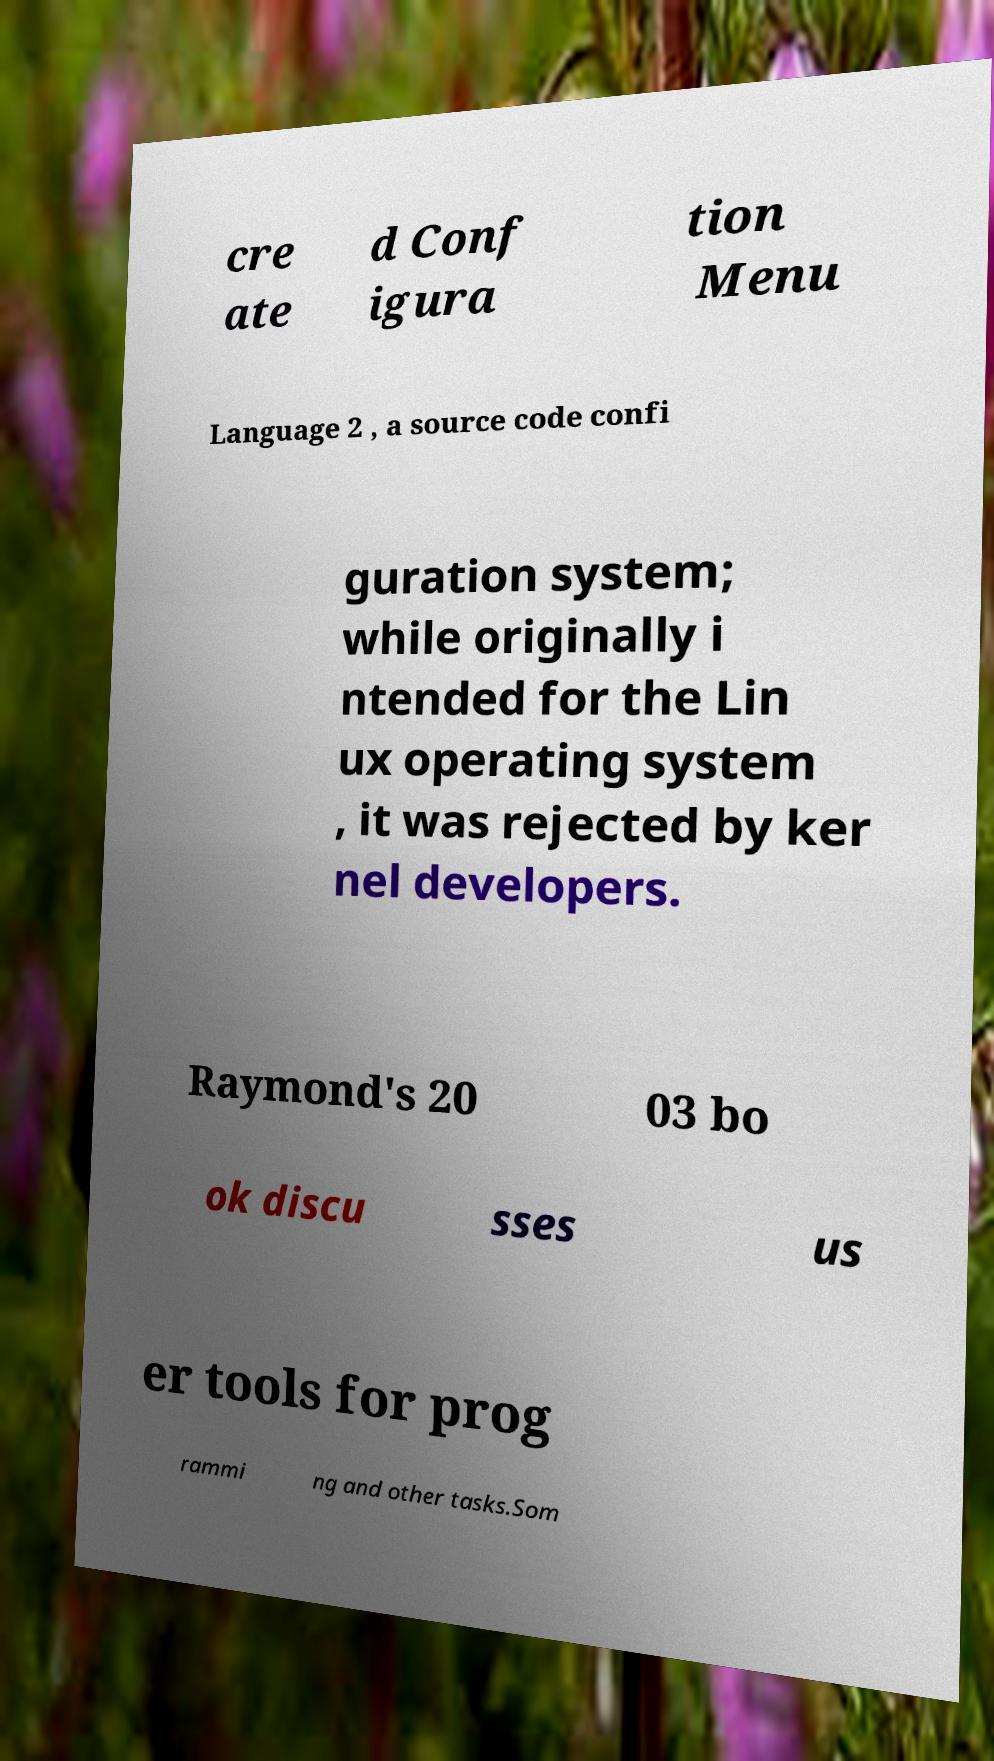There's text embedded in this image that I need extracted. Can you transcribe it verbatim? cre ate d Conf igura tion Menu Language 2 , a source code confi guration system; while originally i ntended for the Lin ux operating system , it was rejected by ker nel developers. Raymond's 20 03 bo ok discu sses us er tools for prog rammi ng and other tasks.Som 